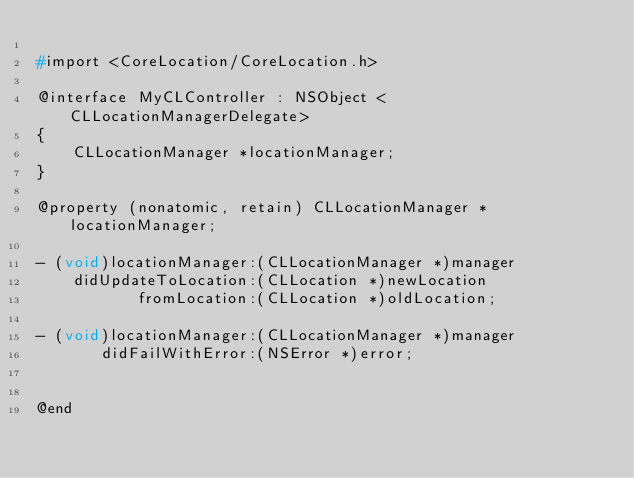<code> <loc_0><loc_0><loc_500><loc_500><_C_>
#import <CoreLocation/CoreLocation.h>

@interface MyCLController : NSObject <CLLocationManagerDelegate>
{
    CLLocationManager *locationManager;
}

@property (nonatomic, retain) CLLocationManager *locationManager;

- (void)locationManager:(CLLocationManager *)manager
    didUpdateToLocation:(CLLocation *)newLocation
           fromLocation:(CLLocation *)oldLocation;

- (void)locationManager:(CLLocationManager *)manager
       didFailWithError:(NSError *)error;


@end
</code> 